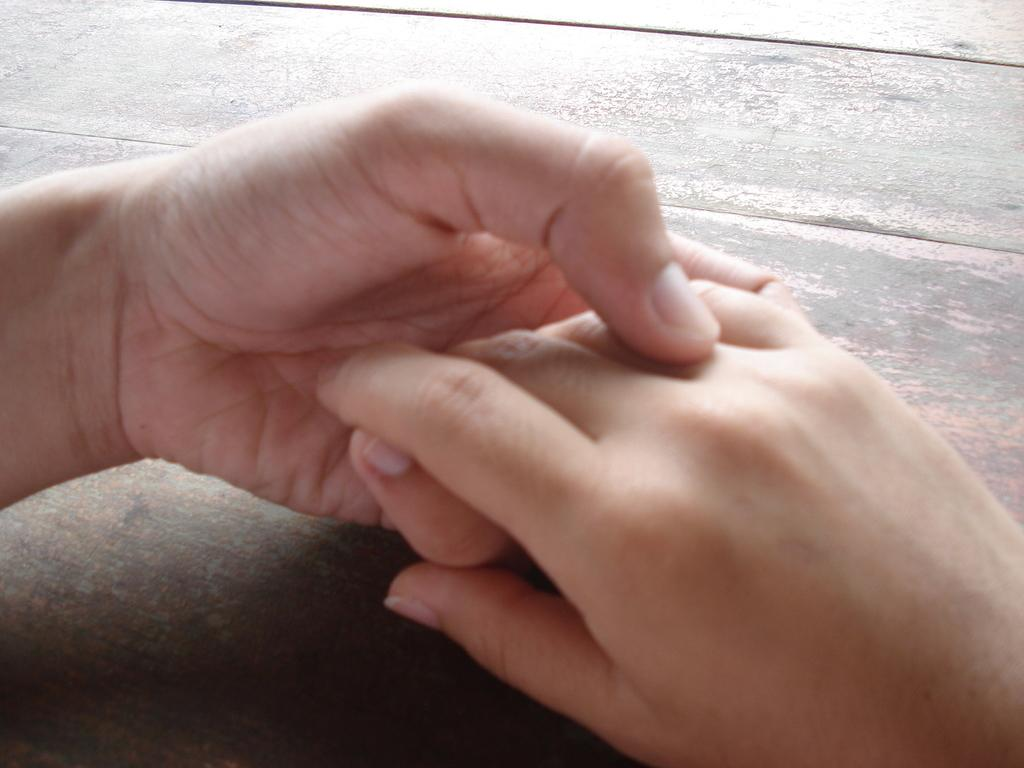What body part is visible in the image? There are hands visible in the image. Where are the hands located? The hands are on a table. What island is being explored in the image? There is no island present in the image; it only features hands on a table. 